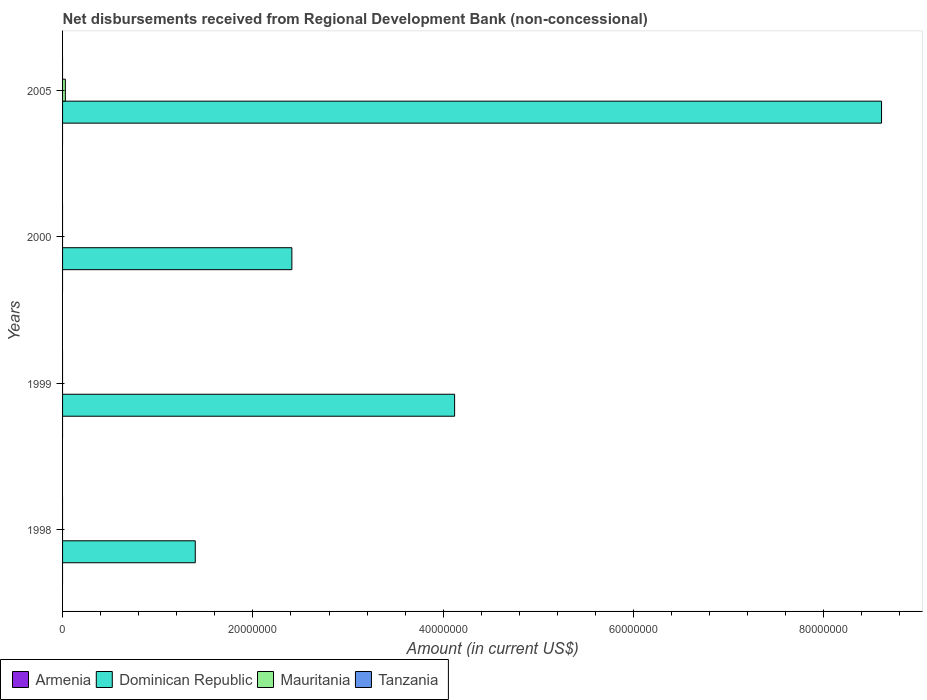How many different coloured bars are there?
Provide a short and direct response. 2. Are the number of bars on each tick of the Y-axis equal?
Keep it short and to the point. No. How many bars are there on the 2nd tick from the bottom?
Offer a very short reply. 1. Across all years, what is the maximum amount of disbursements received from Regional Development Bank in Mauritania?
Your answer should be very brief. 2.94e+05. Across all years, what is the minimum amount of disbursements received from Regional Development Bank in Armenia?
Offer a terse response. 0. What is the total amount of disbursements received from Regional Development Bank in Tanzania in the graph?
Your answer should be very brief. 0. What is the difference between the amount of disbursements received from Regional Development Bank in Dominican Republic in 1998 and that in 1999?
Your answer should be compact. -2.73e+07. What is the difference between the amount of disbursements received from Regional Development Bank in Tanzania in 2005 and the amount of disbursements received from Regional Development Bank in Dominican Republic in 1999?
Keep it short and to the point. -4.12e+07. What is the ratio of the amount of disbursements received from Regional Development Bank in Dominican Republic in 1999 to that in 2000?
Give a very brief answer. 1.71. What is the difference between the highest and the second highest amount of disbursements received from Regional Development Bank in Dominican Republic?
Make the answer very short. 4.49e+07. What is the difference between the highest and the lowest amount of disbursements received from Regional Development Bank in Mauritania?
Your answer should be compact. 2.94e+05. In how many years, is the amount of disbursements received from Regional Development Bank in Mauritania greater than the average amount of disbursements received from Regional Development Bank in Mauritania taken over all years?
Offer a very short reply. 1. Is the sum of the amount of disbursements received from Regional Development Bank in Dominican Republic in 1999 and 2000 greater than the maximum amount of disbursements received from Regional Development Bank in Armenia across all years?
Offer a very short reply. Yes. Is it the case that in every year, the sum of the amount of disbursements received from Regional Development Bank in Tanzania and amount of disbursements received from Regional Development Bank in Dominican Republic is greater than the amount of disbursements received from Regional Development Bank in Armenia?
Your answer should be very brief. Yes. How many bars are there?
Ensure brevity in your answer.  5. How many years are there in the graph?
Make the answer very short. 4. What is the difference between two consecutive major ticks on the X-axis?
Offer a very short reply. 2.00e+07. Does the graph contain any zero values?
Your answer should be very brief. Yes. Does the graph contain grids?
Ensure brevity in your answer.  No. Where does the legend appear in the graph?
Offer a terse response. Bottom left. How many legend labels are there?
Offer a terse response. 4. How are the legend labels stacked?
Your answer should be compact. Horizontal. What is the title of the graph?
Give a very brief answer. Net disbursements received from Regional Development Bank (non-concessional). Does "Lithuania" appear as one of the legend labels in the graph?
Your answer should be compact. No. What is the Amount (in current US$) of Armenia in 1998?
Offer a very short reply. 0. What is the Amount (in current US$) in Dominican Republic in 1998?
Offer a very short reply. 1.39e+07. What is the Amount (in current US$) in Mauritania in 1998?
Your answer should be very brief. 0. What is the Amount (in current US$) in Armenia in 1999?
Make the answer very short. 0. What is the Amount (in current US$) of Dominican Republic in 1999?
Give a very brief answer. 4.12e+07. What is the Amount (in current US$) in Mauritania in 1999?
Make the answer very short. 0. What is the Amount (in current US$) in Tanzania in 1999?
Offer a very short reply. 0. What is the Amount (in current US$) of Dominican Republic in 2000?
Provide a short and direct response. 2.41e+07. What is the Amount (in current US$) in Mauritania in 2000?
Give a very brief answer. 0. What is the Amount (in current US$) in Dominican Republic in 2005?
Provide a succinct answer. 8.61e+07. What is the Amount (in current US$) in Mauritania in 2005?
Provide a short and direct response. 2.94e+05. Across all years, what is the maximum Amount (in current US$) of Dominican Republic?
Make the answer very short. 8.61e+07. Across all years, what is the maximum Amount (in current US$) in Mauritania?
Give a very brief answer. 2.94e+05. Across all years, what is the minimum Amount (in current US$) of Dominican Republic?
Provide a succinct answer. 1.39e+07. Across all years, what is the minimum Amount (in current US$) of Mauritania?
Offer a very short reply. 0. What is the total Amount (in current US$) in Armenia in the graph?
Your response must be concise. 0. What is the total Amount (in current US$) in Dominican Republic in the graph?
Your answer should be very brief. 1.65e+08. What is the total Amount (in current US$) in Mauritania in the graph?
Keep it short and to the point. 2.94e+05. What is the difference between the Amount (in current US$) in Dominican Republic in 1998 and that in 1999?
Ensure brevity in your answer.  -2.73e+07. What is the difference between the Amount (in current US$) of Dominican Republic in 1998 and that in 2000?
Provide a short and direct response. -1.02e+07. What is the difference between the Amount (in current US$) in Dominican Republic in 1998 and that in 2005?
Provide a succinct answer. -7.21e+07. What is the difference between the Amount (in current US$) of Dominican Republic in 1999 and that in 2000?
Provide a succinct answer. 1.71e+07. What is the difference between the Amount (in current US$) in Dominican Republic in 1999 and that in 2005?
Your answer should be very brief. -4.49e+07. What is the difference between the Amount (in current US$) of Dominican Republic in 2000 and that in 2005?
Ensure brevity in your answer.  -6.20e+07. What is the difference between the Amount (in current US$) in Dominican Republic in 1998 and the Amount (in current US$) in Mauritania in 2005?
Keep it short and to the point. 1.37e+07. What is the difference between the Amount (in current US$) of Dominican Republic in 1999 and the Amount (in current US$) of Mauritania in 2005?
Make the answer very short. 4.09e+07. What is the difference between the Amount (in current US$) in Dominican Republic in 2000 and the Amount (in current US$) in Mauritania in 2005?
Keep it short and to the point. 2.38e+07. What is the average Amount (in current US$) of Dominican Republic per year?
Make the answer very short. 4.13e+07. What is the average Amount (in current US$) of Mauritania per year?
Keep it short and to the point. 7.35e+04. In the year 2005, what is the difference between the Amount (in current US$) of Dominican Republic and Amount (in current US$) of Mauritania?
Ensure brevity in your answer.  8.58e+07. What is the ratio of the Amount (in current US$) in Dominican Republic in 1998 to that in 1999?
Offer a very short reply. 0.34. What is the ratio of the Amount (in current US$) in Dominican Republic in 1998 to that in 2000?
Make the answer very short. 0.58. What is the ratio of the Amount (in current US$) in Dominican Republic in 1998 to that in 2005?
Your answer should be very brief. 0.16. What is the ratio of the Amount (in current US$) of Dominican Republic in 1999 to that in 2000?
Ensure brevity in your answer.  1.71. What is the ratio of the Amount (in current US$) in Dominican Republic in 1999 to that in 2005?
Provide a short and direct response. 0.48. What is the ratio of the Amount (in current US$) of Dominican Republic in 2000 to that in 2005?
Provide a succinct answer. 0.28. What is the difference between the highest and the second highest Amount (in current US$) of Dominican Republic?
Provide a short and direct response. 4.49e+07. What is the difference between the highest and the lowest Amount (in current US$) in Dominican Republic?
Provide a short and direct response. 7.21e+07. What is the difference between the highest and the lowest Amount (in current US$) of Mauritania?
Your response must be concise. 2.94e+05. 